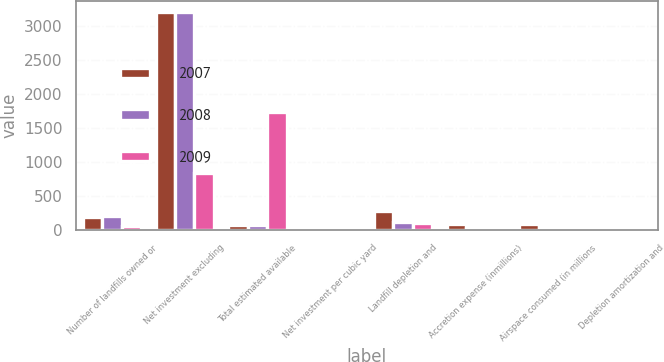Convert chart. <chart><loc_0><loc_0><loc_500><loc_500><stacked_bar_chart><ecel><fcel>Number of landfills owned or<fcel>Net investment excluding<fcel>Total estimated available<fcel>Net investment per cubic yard<fcel>Landfill depletion and<fcel>Accretion expense (inmillions)<fcel>Airspace consumed (in millions<fcel>Depletion amortization and<nl><fcel>2007<fcel>192<fcel>3200.6<fcel>72.45<fcel>0.69<fcel>278.5<fcel>88.8<fcel>86.9<fcel>4.23<nl><fcel>2008<fcel>213<fcel>3198.3<fcel>72.45<fcel>0.65<fcel>119.7<fcel>23.9<fcel>42.7<fcel>3.36<nl><fcel>2009<fcel>58<fcel>836<fcel>1729.3<fcel>0.48<fcel>110.1<fcel>17.1<fcel>40.3<fcel>3.16<nl></chart> 